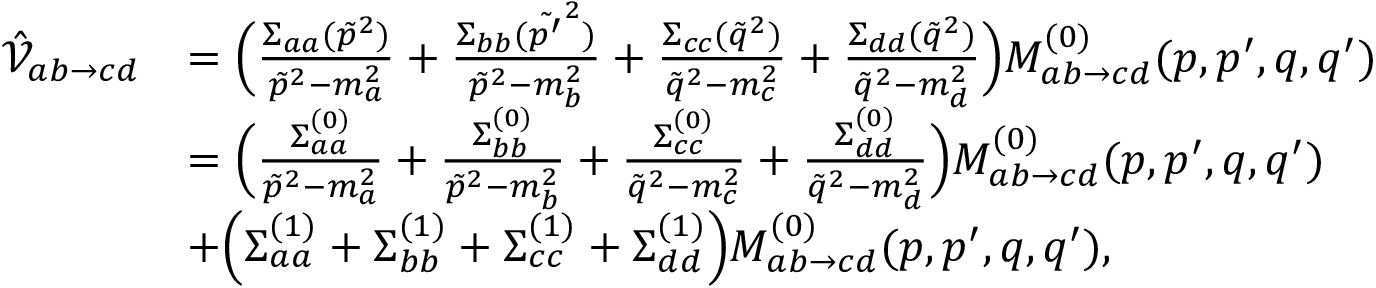Convert formula to latex. <formula><loc_0><loc_0><loc_500><loc_500>\begin{array} { r l } { \hat { \mathcal { V } } _ { a b \to c d } } & { = \left ( \frac { \Sigma _ { a a } ( \tilde { p } ^ { 2 } ) } { \tilde { p } ^ { 2 } - m _ { a } ^ { 2 } } + \frac { \Sigma _ { b b } ( \tilde { p ^ { \prime } } ^ { 2 } ) } { \tilde { p } ^ { 2 } - m _ { b } ^ { 2 } } + \frac { \Sigma _ { c c } ( \tilde { q } ^ { 2 } ) } { \tilde { q } ^ { 2 } - m _ { c } ^ { 2 } } + \frac { \Sigma _ { d d } ( \tilde { q } ^ { 2 } ) } { \tilde { q } ^ { 2 } - m _ { d } ^ { 2 } } \right ) M _ { a b \to c d } ^ { ( 0 ) } ( p , p ^ { \prime } , q , q ^ { \prime } ) } \\ & { = \left ( \frac { \Sigma _ { a a } ^ { ( 0 ) } } { \tilde { p } ^ { 2 } - m _ { a } ^ { 2 } } + \frac { \Sigma _ { b b } ^ { ( 0 ) } } { \tilde { p } ^ { 2 } - m _ { b } ^ { 2 } } + \frac { \Sigma _ { c c } ^ { ( 0 ) } } { \tilde { q } ^ { 2 } - m _ { c } ^ { 2 } } + \frac { \Sigma _ { d d } ^ { ( 0 ) } } { \tilde { q } ^ { 2 } - m _ { d } ^ { 2 } } \right ) M _ { a b \to c d } ^ { ( 0 ) } ( p , p ^ { \prime } , q , q ^ { \prime } ) } \\ & { + \left ( \Sigma _ { a a } ^ { ( 1 ) } + \Sigma _ { b b } ^ { ( 1 ) } + \Sigma _ { c c } ^ { ( 1 ) } + \Sigma _ { d d } ^ { ( 1 ) } \right ) M _ { a b \to c d } ^ { ( 0 ) } ( p , p ^ { \prime } , q , q ^ { \prime } ) , } \end{array}</formula> 